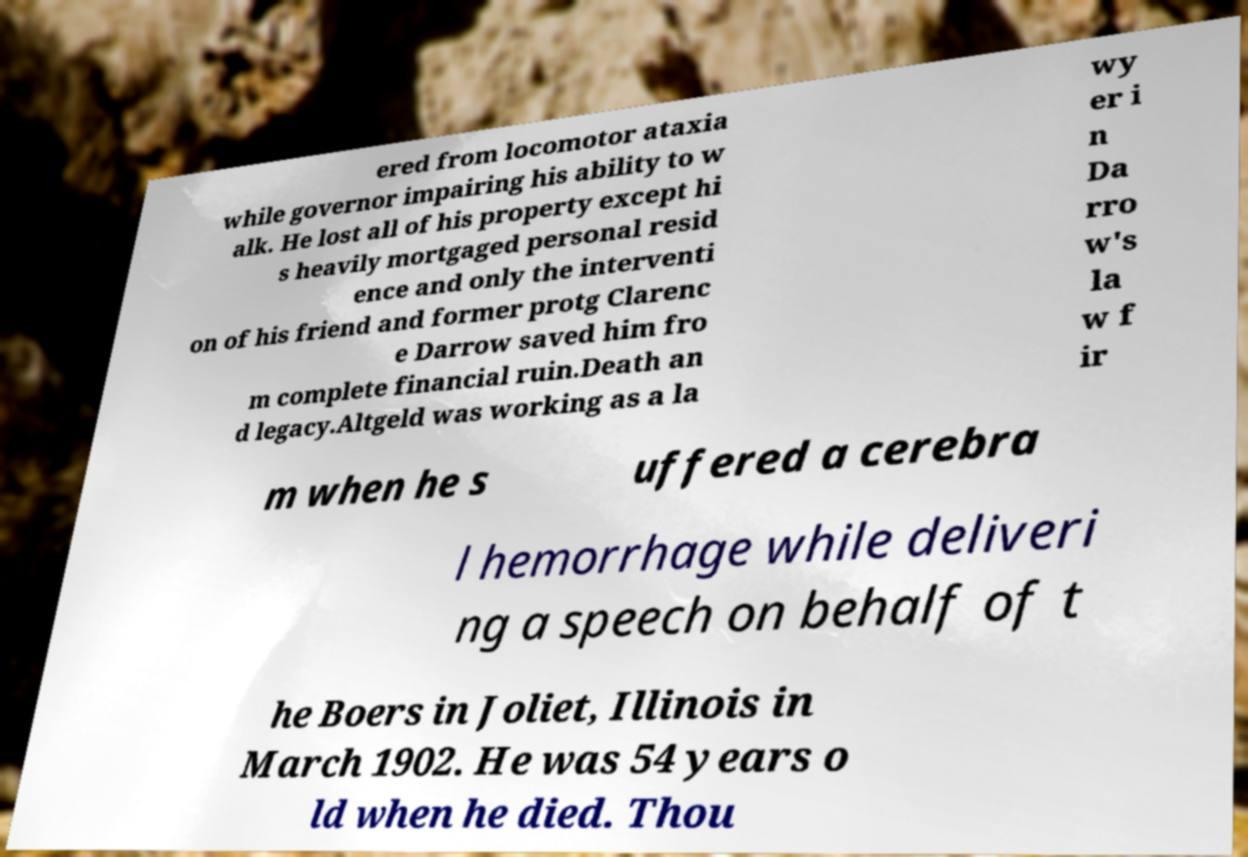For documentation purposes, I need the text within this image transcribed. Could you provide that? ered from locomotor ataxia while governor impairing his ability to w alk. He lost all of his property except hi s heavily mortgaged personal resid ence and only the interventi on of his friend and former protg Clarenc e Darrow saved him fro m complete financial ruin.Death an d legacy.Altgeld was working as a la wy er i n Da rro w's la w f ir m when he s uffered a cerebra l hemorrhage while deliveri ng a speech on behalf of t he Boers in Joliet, Illinois in March 1902. He was 54 years o ld when he died. Thou 